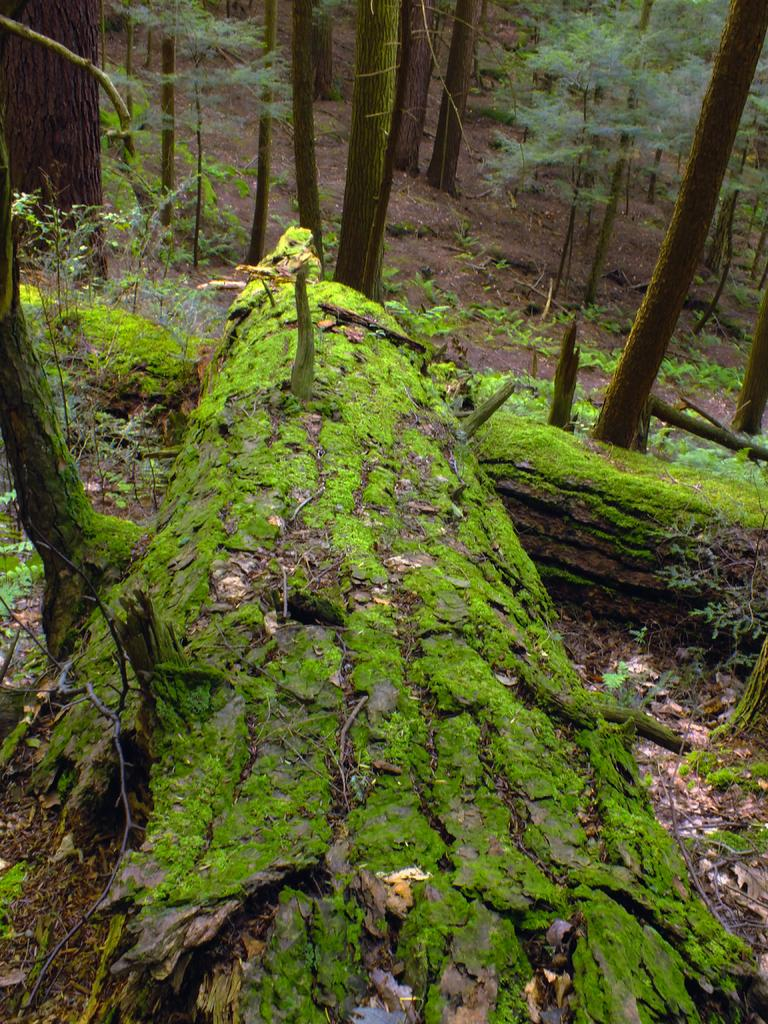What type of surface is visible in the image? The image contains the ground. What type of vegetation can be seen in the image? There are trees and plants in the image. What type of belief is represented by the flag in the image? There is no flag present in the image, so it is not possible to determine what belief might be represented. 